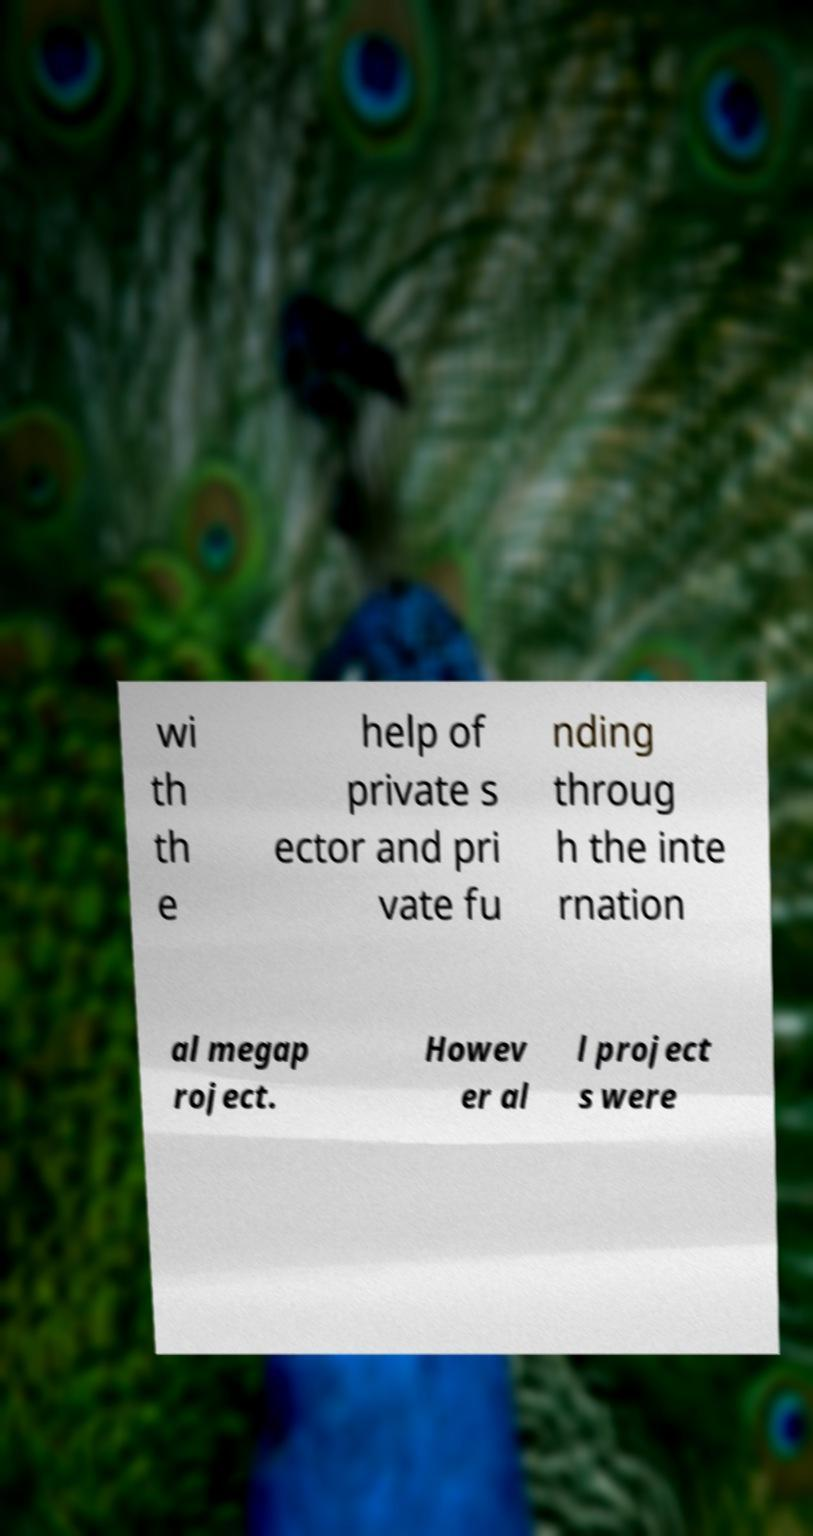Could you extract and type out the text from this image? wi th th e help of private s ector and pri vate fu nding throug h the inte rnation al megap roject. Howev er al l project s were 